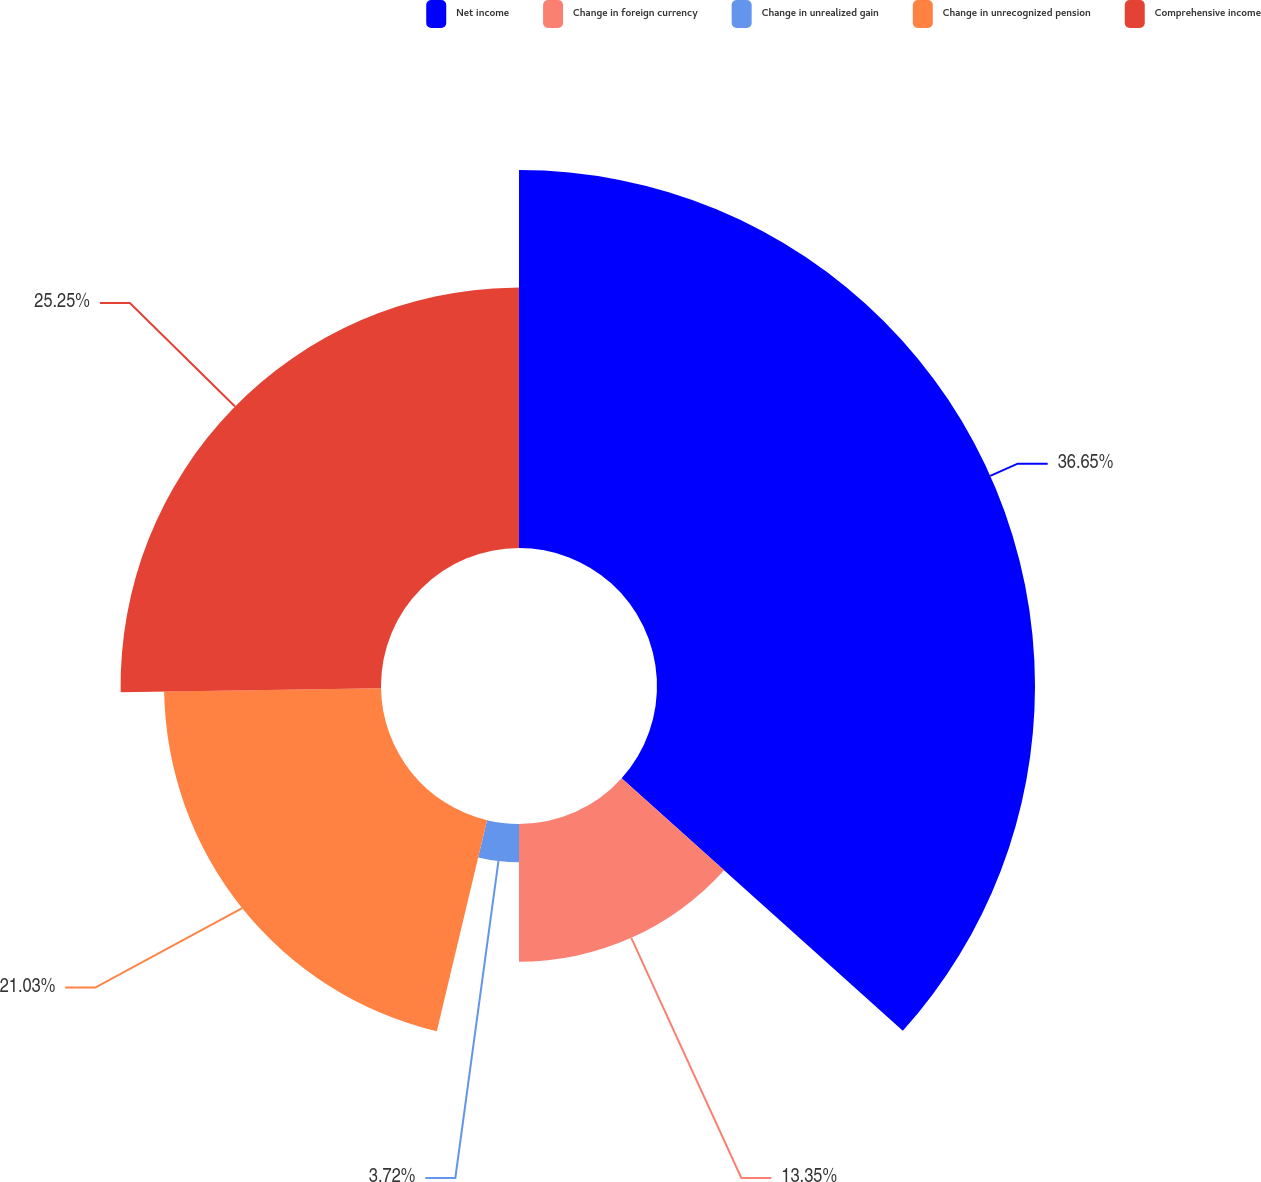<chart> <loc_0><loc_0><loc_500><loc_500><pie_chart><fcel>Net income<fcel>Change in foreign currency<fcel>Change in unrealized gain<fcel>Change in unrecognized pension<fcel>Comprehensive income<nl><fcel>36.65%<fcel>13.35%<fcel>3.72%<fcel>21.03%<fcel>25.25%<nl></chart> 